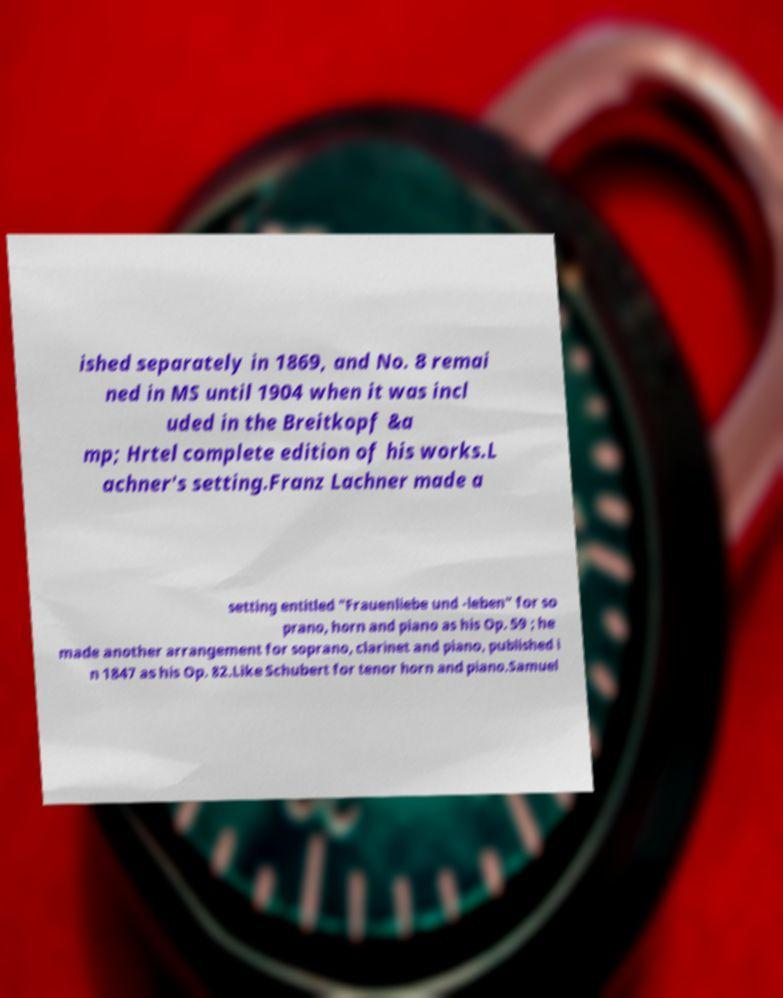Could you extract and type out the text from this image? ished separately in 1869, and No. 8 remai ned in MS until 1904 when it was incl uded in the Breitkopf &a mp; Hrtel complete edition of his works.L achner's setting.Franz Lachner made a setting entitled "Frauenliebe und -leben" for so prano, horn and piano as his Op. 59 ; he made another arrangement for soprano, clarinet and piano, published i n 1847 as his Op. 82.Like Schubert for tenor horn and piano.Samuel 